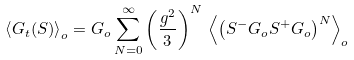Convert formula to latex. <formula><loc_0><loc_0><loc_500><loc_500>\left \langle G _ { t } ( { S } ) \right \rangle _ { o } = G _ { o } \sum _ { N = 0 } ^ { \infty } \left ( \frac { g ^ { 2 } } { 3 } \right ) ^ { N } \, \left \langle \left ( S ^ { - } G _ { o } S ^ { + } G _ { o } \right ) ^ { N } \right \rangle _ { o }</formula> 